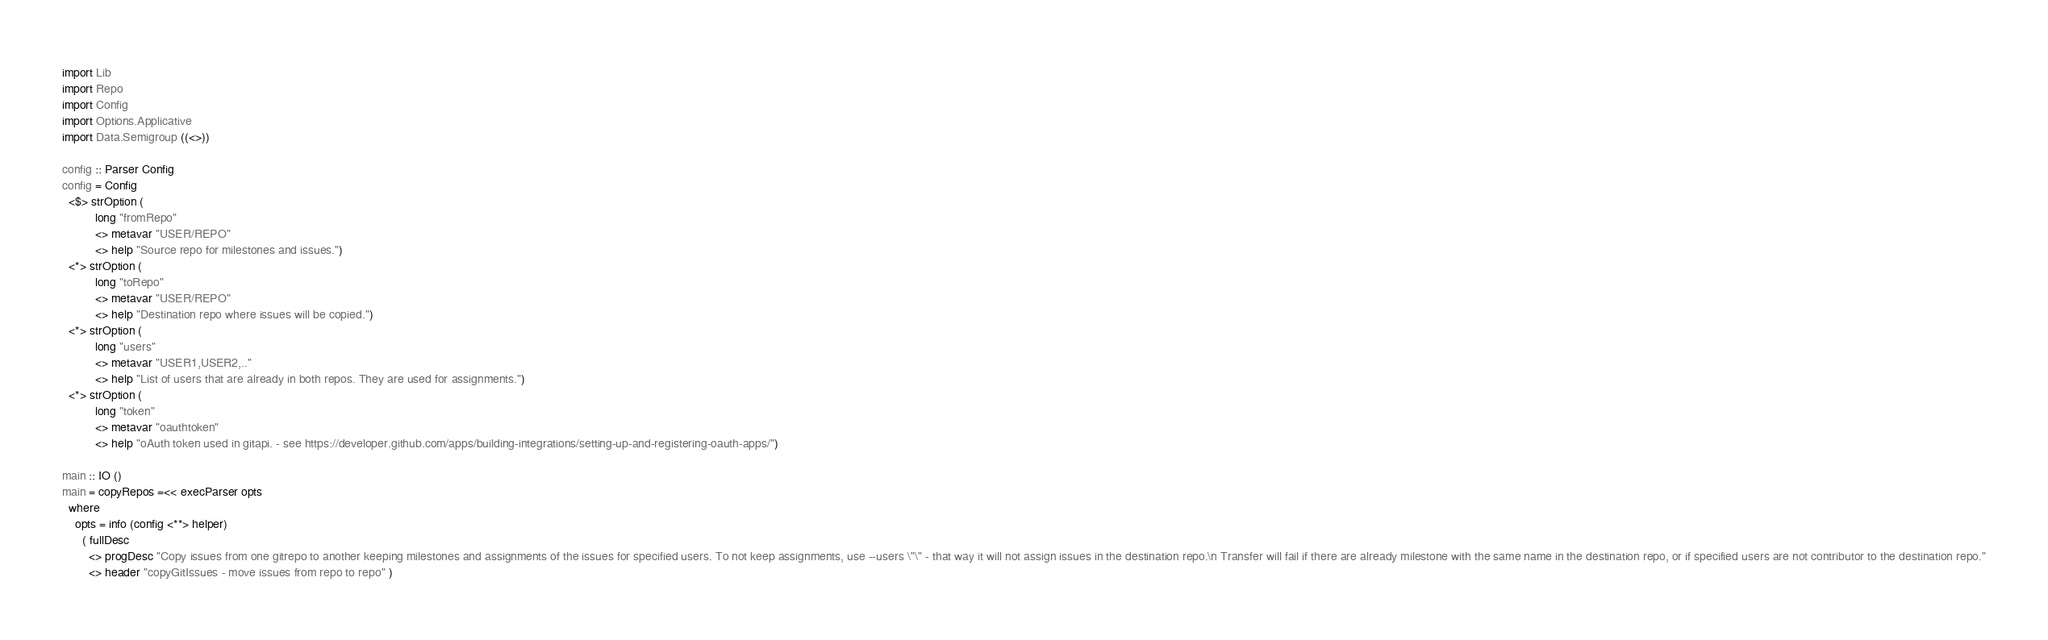Convert code to text. <code><loc_0><loc_0><loc_500><loc_500><_Haskell_>import Lib
import Repo
import Config
import Options.Applicative
import Data.Semigroup ((<>))

config :: Parser Config
config = Config
  <$> strOption (
          long "fromRepo"
          <> metavar "USER/REPO"
          <> help "Source repo for milestones and issues.")
  <*> strOption (
          long "toRepo"
          <> metavar "USER/REPO"
          <> help "Destination repo where issues will be copied.")
  <*> strOption (
          long "users"
          <> metavar "USER1,USER2,.."
          <> help "List of users that are already in both repos. They are used for assignments.")
  <*> strOption (
          long "token"
          <> metavar "oauthtoken"
          <> help "oAuth token used in gitapi. - see https://developer.github.com/apps/building-integrations/setting-up-and-registering-oauth-apps/")
  
main :: IO ()
main = copyRepos =<< execParser opts
  where
    opts = info (config <**> helper)
      ( fullDesc
        <> progDesc "Copy issues from one gitrepo to another keeping milestones and assignments of the issues for specified users. To not keep assignments, use --users \"\" - that way it will not assign issues in the destination repo.\n Transfer will fail if there are already milestone with the same name in the destination repo, or if specified users are not contributor to the destination repo."
        <> header "copyGitIssues - move issues from repo to repo" )

</code> 